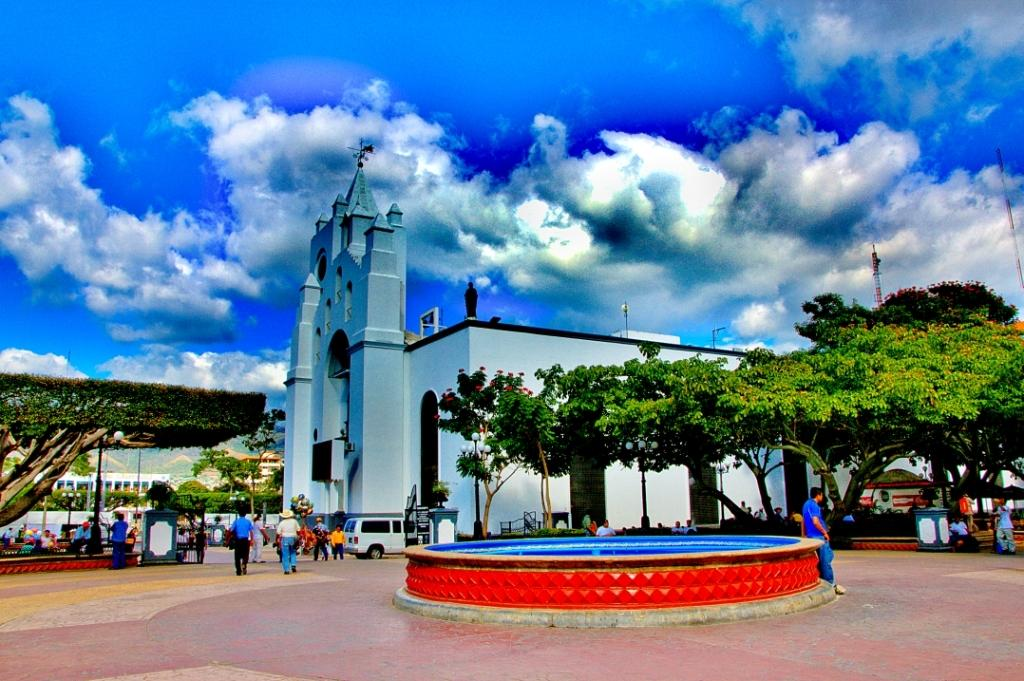What type of picture is the image? The image is an animated picture. What can be seen in the sky in the image? There is a sky with clouds in the image. What structures are present in the image? There are buildings in the image. What type of vegetation is in the image? There are trees in the image. What are the poles used for in the image? The purpose of the poles in the image is not specified, but they could be used for various purposes such as streetlights or signage. What is on the ground in the image? There are motor vehicles on the ground in the image. What are the people in the image doing? There are people standing on the floor in the image. What type of lettuce is being used as a prop in the image? There is no lettuce present in the image. 